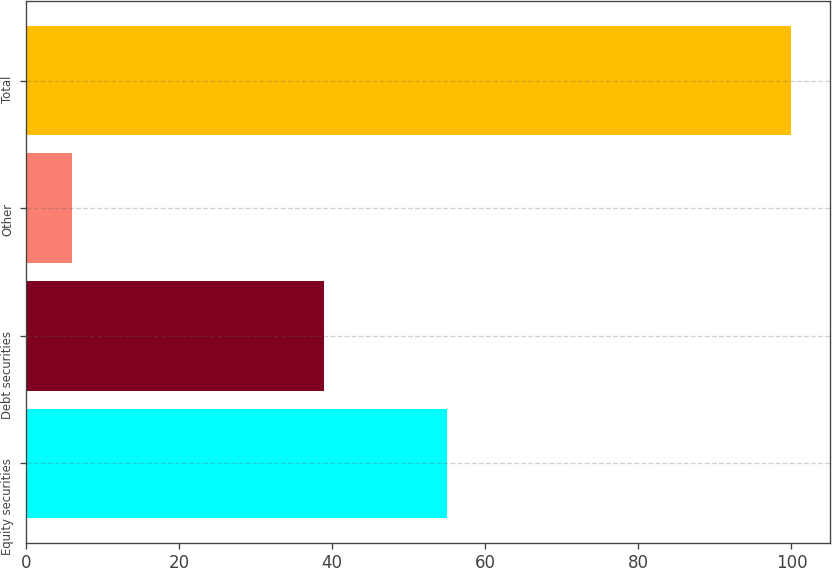Convert chart. <chart><loc_0><loc_0><loc_500><loc_500><bar_chart><fcel>Equity securities<fcel>Debt securities<fcel>Other<fcel>Total<nl><fcel>55<fcel>39<fcel>6<fcel>100<nl></chart> 